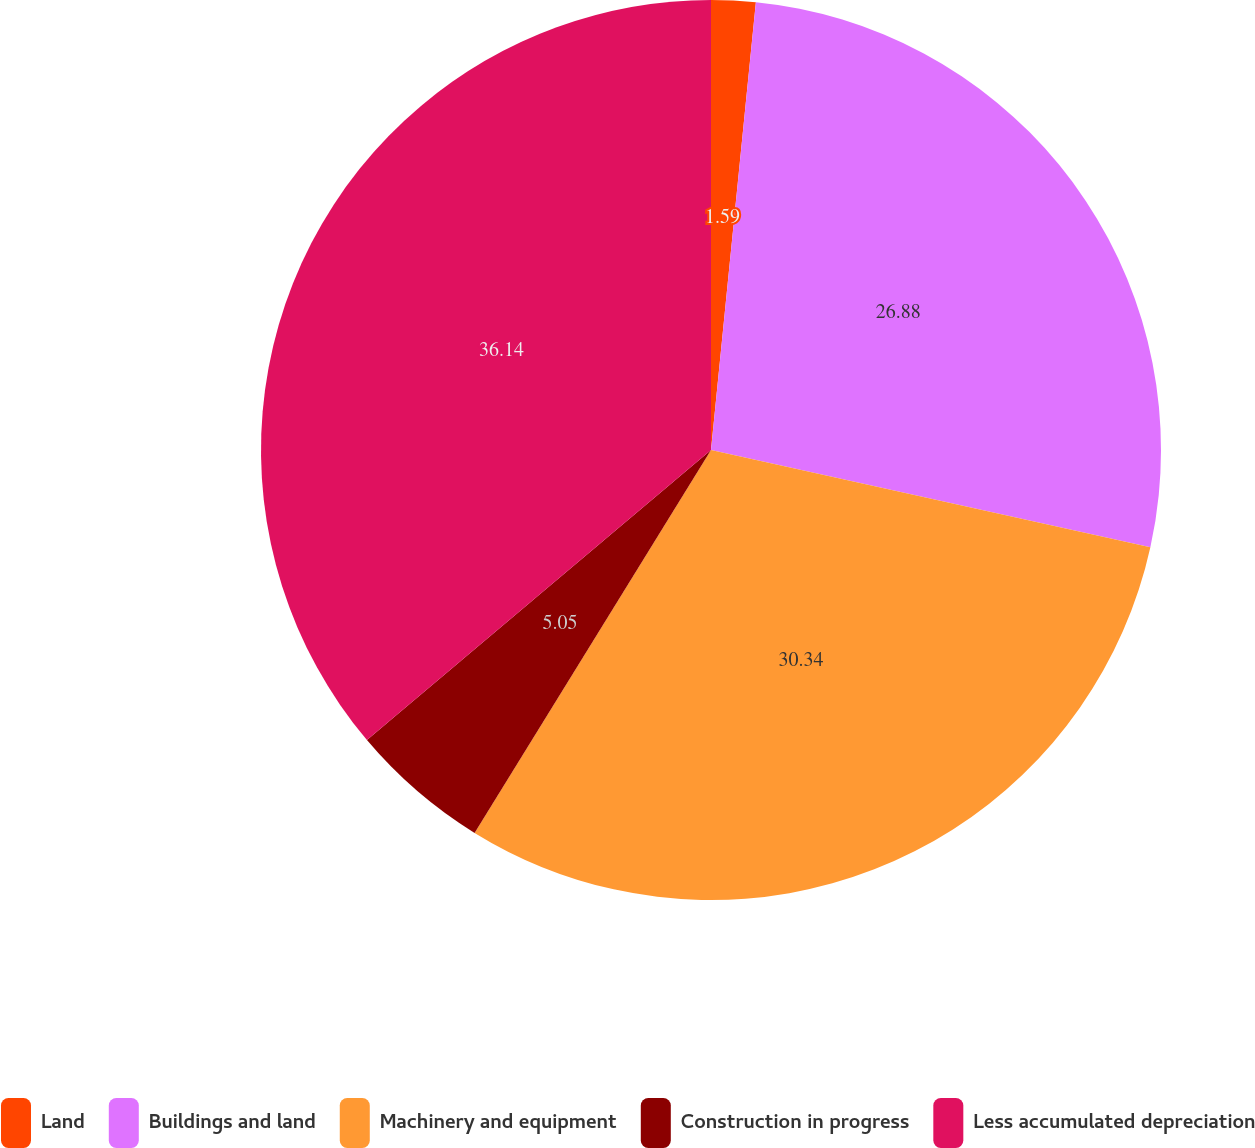Convert chart to OTSL. <chart><loc_0><loc_0><loc_500><loc_500><pie_chart><fcel>Land<fcel>Buildings and land<fcel>Machinery and equipment<fcel>Construction in progress<fcel>Less accumulated depreciation<nl><fcel>1.59%<fcel>26.88%<fcel>30.34%<fcel>5.05%<fcel>36.15%<nl></chart> 